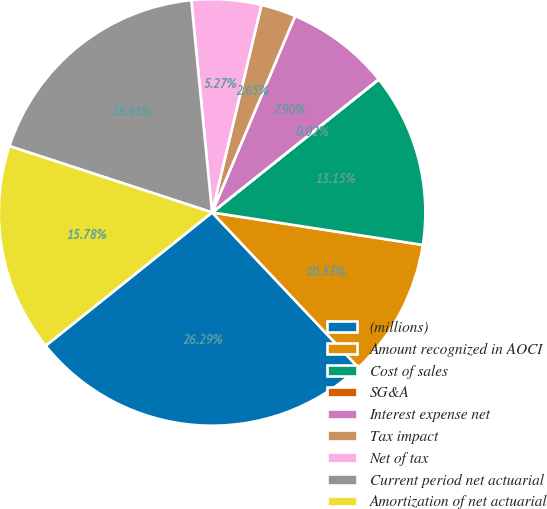Convert chart to OTSL. <chart><loc_0><loc_0><loc_500><loc_500><pie_chart><fcel>(millions)<fcel>Amount recognized in AOCI<fcel>Cost of sales<fcel>SG&A<fcel>Interest expense net<fcel>Tax impact<fcel>Net of tax<fcel>Current period net actuarial<fcel>Amortization of net actuarial<nl><fcel>26.29%<fcel>10.53%<fcel>13.15%<fcel>0.02%<fcel>7.9%<fcel>2.65%<fcel>5.27%<fcel>18.41%<fcel>15.78%<nl></chart> 